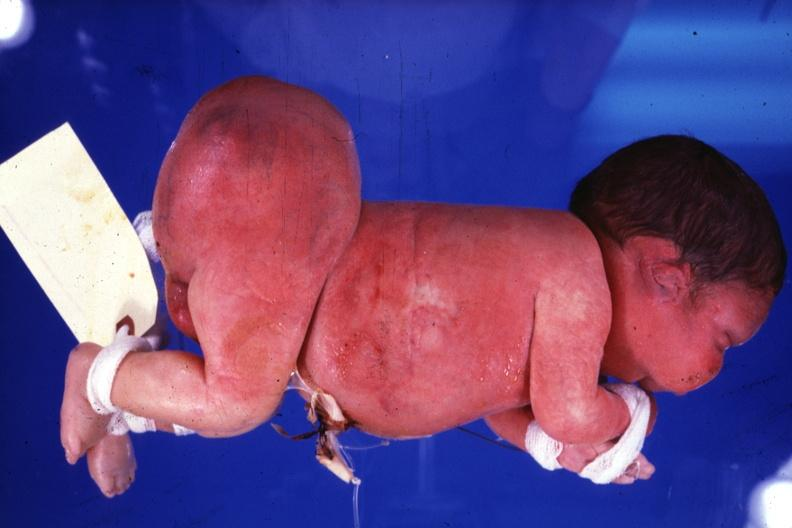s sacrococcygeal teratoma present?
Answer the question using a single word or phrase. Yes 